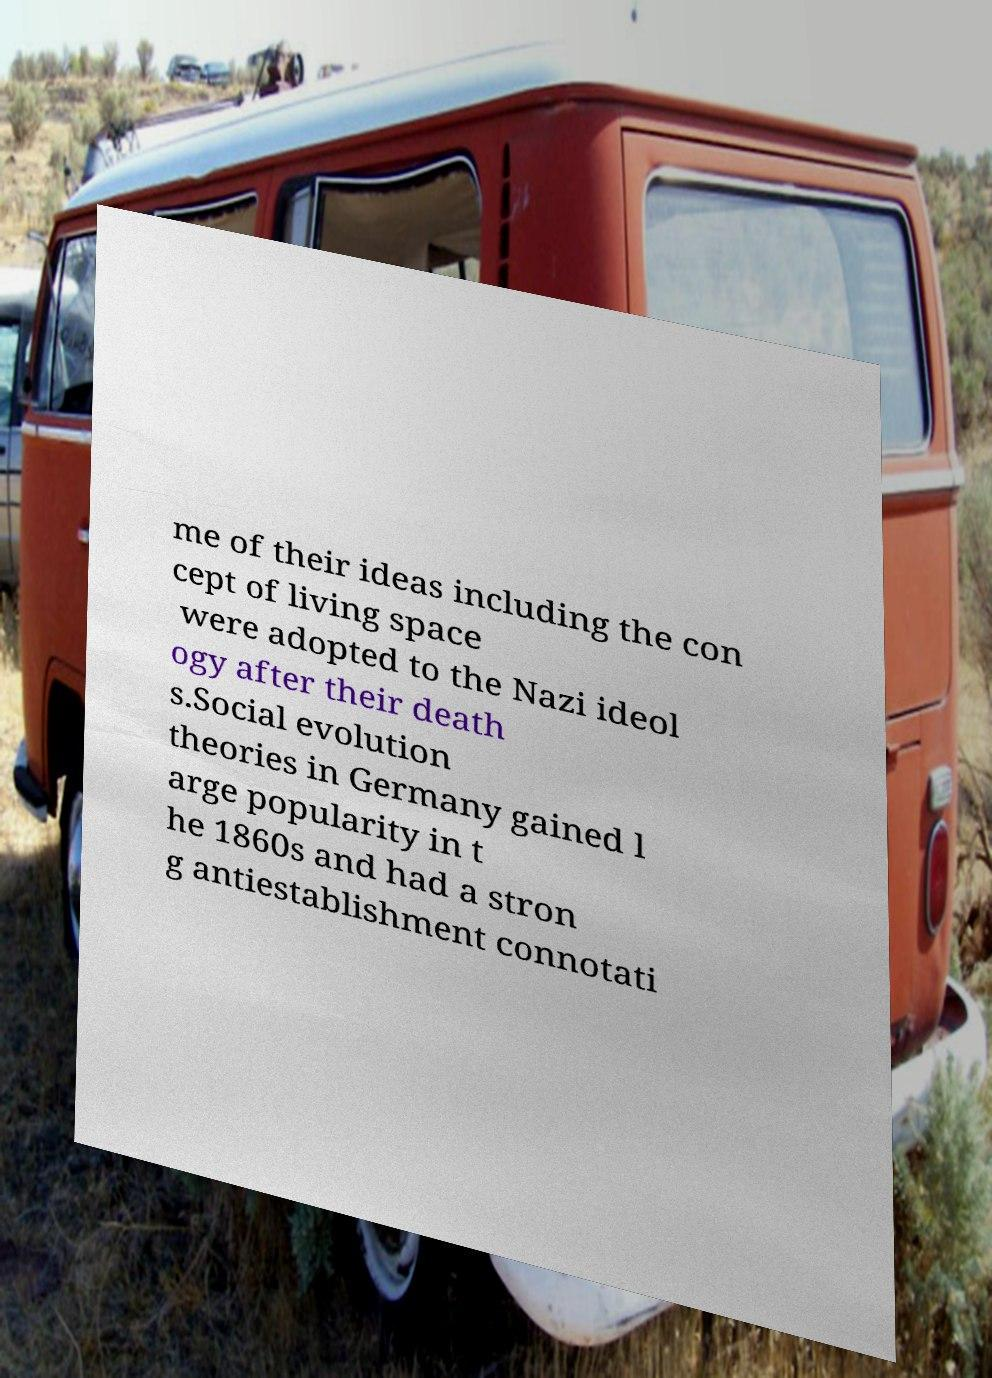I need the written content from this picture converted into text. Can you do that? me of their ideas including the con cept of living space were adopted to the Nazi ideol ogy after their death s.Social evolution theories in Germany gained l arge popularity in t he 1860s and had a stron g antiestablishment connotati 